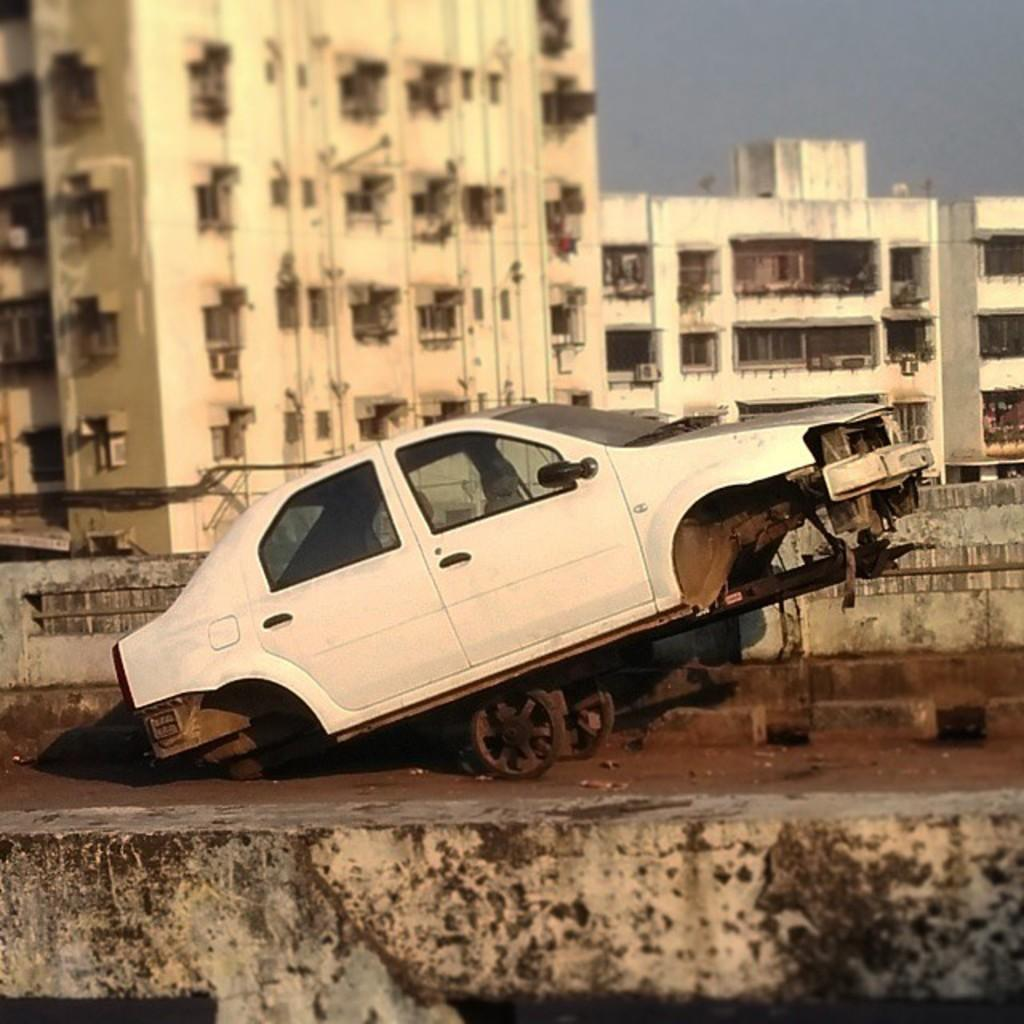What is the main subject of the image? There is a vehicle in the image. What color is the vehicle? The vehicle is white. What can be seen in the background of the image? There are buildings in the background of the image. What color are the buildings? The buildings are cream-colored. What is visible above the buildings? The sky is visible in the image. What color is the sky? The sky is white. How many cans of support can be seen in the image? There are no cans or support structures present in the image. What type of dock is visible in the image? There is no dock present in the image. 